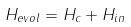<formula> <loc_0><loc_0><loc_500><loc_500>H _ { e v o l } = H _ { c } + H _ { i n }</formula> 